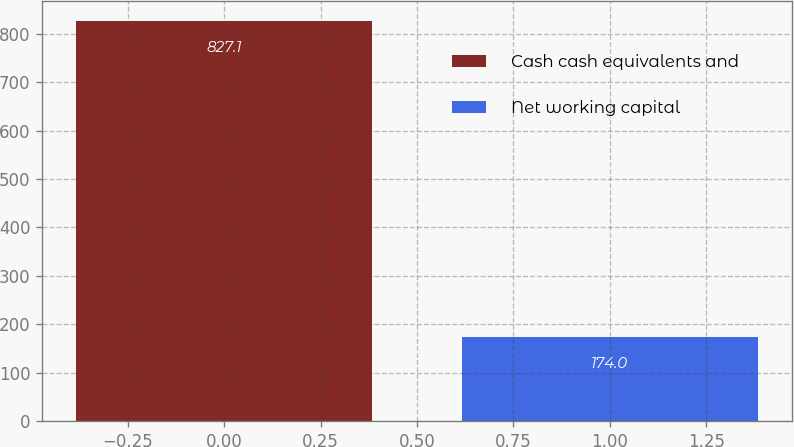Convert chart. <chart><loc_0><loc_0><loc_500><loc_500><bar_chart><fcel>Cash cash equivalents and<fcel>Net working capital<nl><fcel>827.1<fcel>174<nl></chart> 